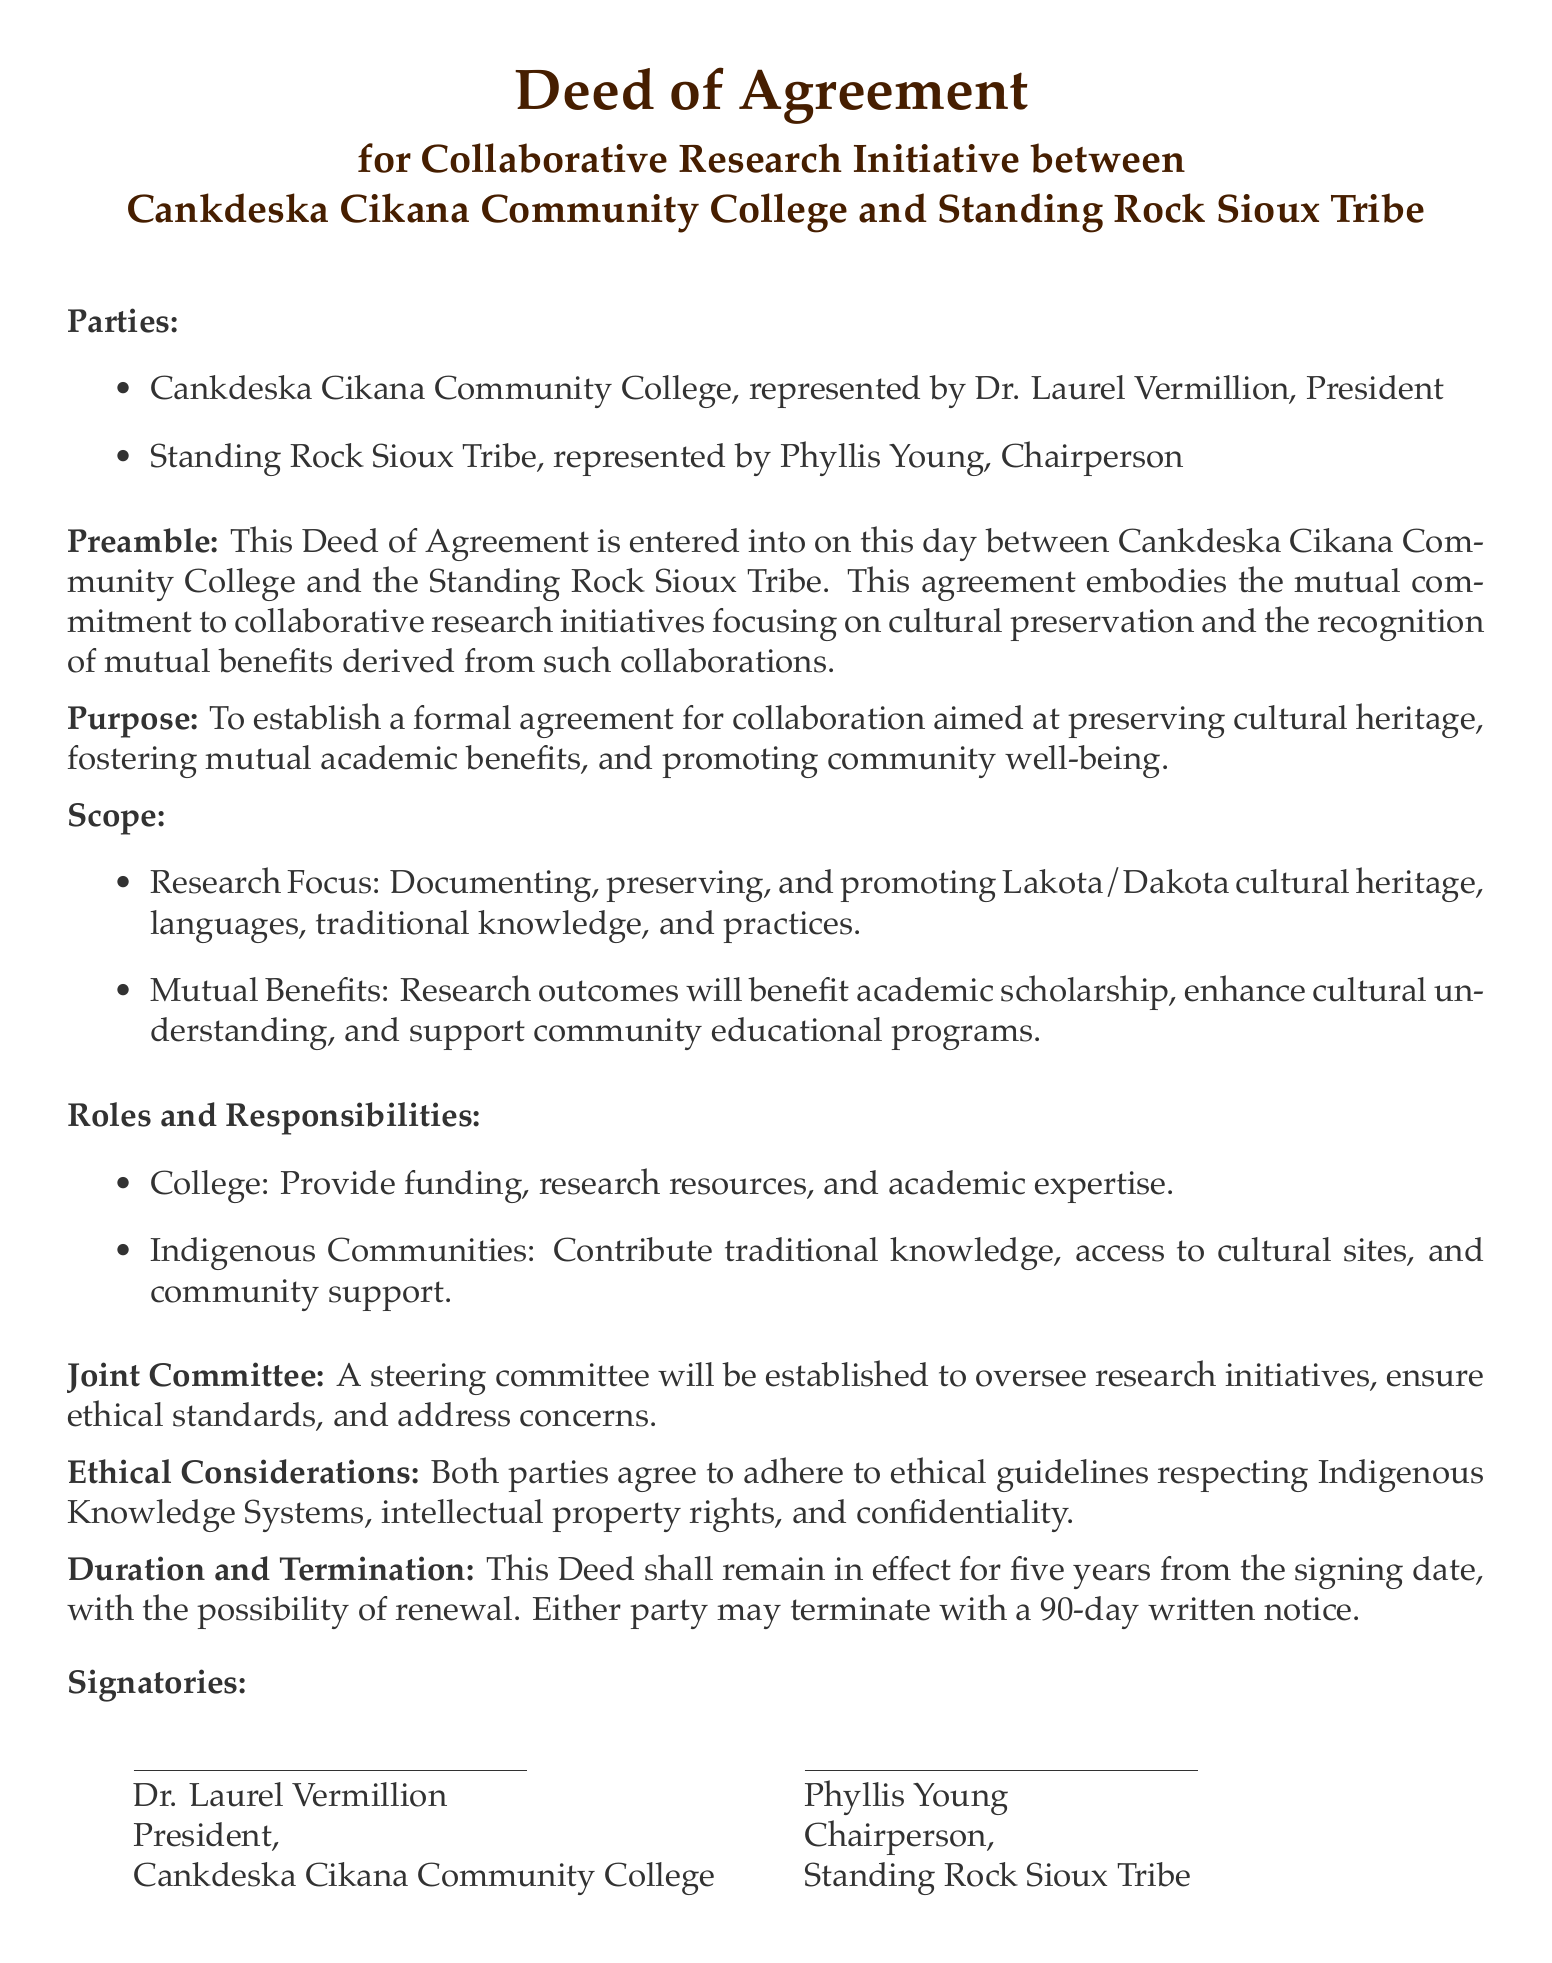What is the title of the document? The title of the document indicates the formal nature of the agreement between the parties involved.
Answer: Deed of Agreement Who represents Cankdeska Cikana Community College? This identifies the person in charge of the college, establishing authority in the agreement.
Answer: Dr. Laurel Vermillion What is the main focus of the collaborative research initiative? This highlights the specific area of research that the agreement aims to address, reflecting the purpose of the collaboration.
Answer: Cultural preservation How long is the duration of the agreement? The document specifies the length of time for which the agreement is valid.
Answer: Five years What responsibilities does the College have according to the document? This outlines the obligations and contributions expected from Cankdeska Cikana Community College as per the agreement.
Answer: Provide funding, research resources, and academic expertise What is the role of the Indigenous Communities as specified in the document? This describes what contributions are expected from the Indigenous partners in the collaboration.
Answer: Contribute traditional knowledge, access to cultural sites, and community support Is there a plan for oversight of the research initiatives? This indicates whether there is a governance structure to ensure the research is conducted ethically and effectively.
Answer: Yes How many days notice is required for termination of the agreement? This specifies the timeframe for notification if either party wishes to end the agreement.
Answer: 90 days 